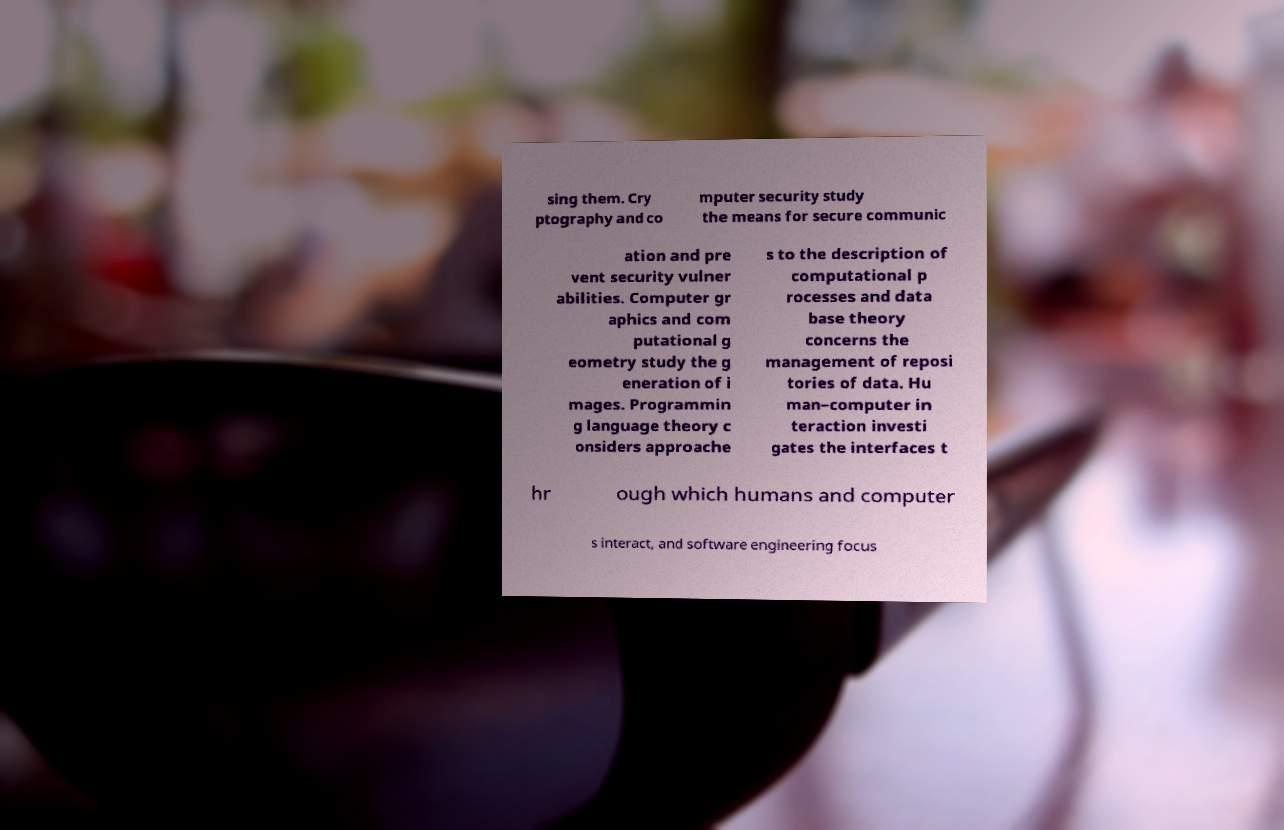Could you assist in decoding the text presented in this image and type it out clearly? sing them. Cry ptography and co mputer security study the means for secure communic ation and pre vent security vulner abilities. Computer gr aphics and com putational g eometry study the g eneration of i mages. Programmin g language theory c onsiders approache s to the description of computational p rocesses and data base theory concerns the management of reposi tories of data. Hu man–computer in teraction investi gates the interfaces t hr ough which humans and computer s interact, and software engineering focus 